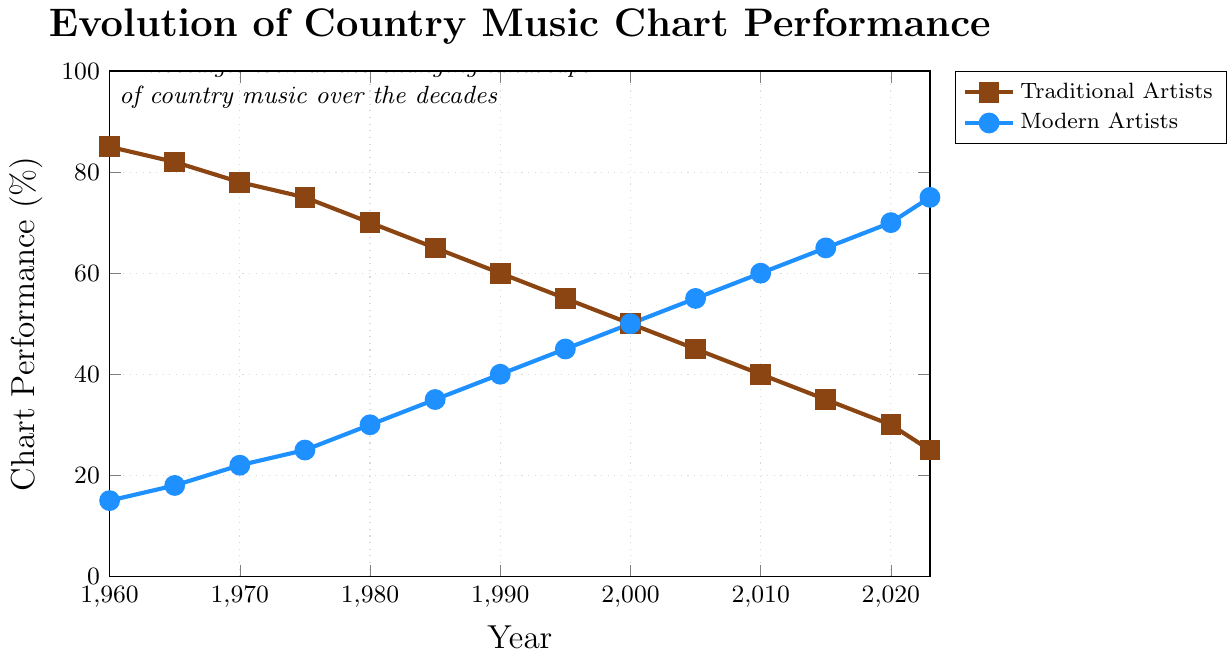What's the overall trend for traditional country artists' chart performance from 1960 to 2023? The chart shows a consistent decline in the chart performance of traditional country artists, starting from 85% in 1960 and dropping to 25% in 2023.
Answer: Decline What's the overall trend for modern country artists' chart performance from 1960 to 2023? The chart indicates a consistent increase in the chart performance of modern country artists, starting from 15% in 1960 and rising to 75% in 2023.
Answer: Increase In which years did modern artists surpass traditional artists in chart performance? By examining the crossing point in the chart: modern artists first surpass traditional artists in chart performance around the year 2000.
Answer: 2000 How much did traditional artists' chart performance decline between 1960 and 2023? Traditional artists' performance declined from 85% in 1960 to 25% in 2023. The difference is 85 - 25 = 60%.
Answer: 60% Compare the chart performance gap between traditional and modern artists in 1980 and 2023. Which year had a larger gap? In 1980, the gap is 70% (traditional) - 30% (modern) = 40%. In 2023, the gap is 75% (modern) - 25% (traditional) = 50%. The gap is larger in 2023.
Answer: 2023 What is the average chart performance for traditional artists from 1960 to 2023? The sum of the data points for traditional artists is (85 + 82 + 78 + 75 + 70 + 65 + 60 + 55 + 50 + 45 + 40 + 35 + 30 + 25) = 795. There are 14 data points, so the average is 795 / 14 ≈ 56.79%.
Answer: 56.79% Around what year did traditional and modern artists have equal chart performance? By observing the chart, around the year 2000, traditional and modern artists have approximately equal chart performances of 50%.
Answer: 2000 By how much did modern artists' chart performance increase from 1990 to 2020? Modern artists' chart performance increased from 40% in 1990 to 70% in 2020. The difference is 70 - 40 = 30%.
Answer: 30% At which points do the two lines cross? The two lines cross only once, around the year 2000, where both traditional and modern artists have a chart performance of 50%.
Answer: 2000 How has the gap between the chart performances of traditional and modern artists changed over the decades? In the 1960s, the gap was in favor of traditional artists (e.g., 85% vs. 15%). Over time, this gap narrowed, disappearing around 2000. In recent decades, the gap favors modern artists, growing larger each decade (e.g., 25% traditional vs. 75% modern in 2023).
Answer: Flipped and widened 